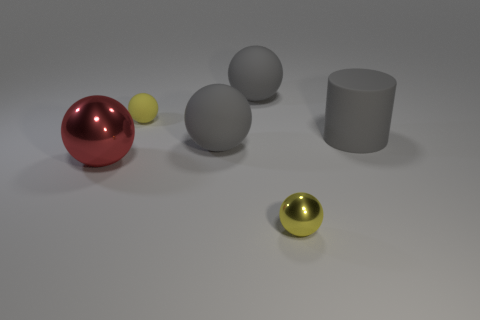Subtract all big rubber balls. How many balls are left? 3 Subtract all yellow balls. How many balls are left? 3 Subtract all red cylinders. How many gray balls are left? 2 Add 2 tiny matte balls. How many tiny matte balls are left? 3 Add 6 brown cylinders. How many brown cylinders exist? 6 Add 3 large cyan metal balls. How many objects exist? 9 Subtract 0 red cylinders. How many objects are left? 6 Subtract all spheres. How many objects are left? 1 Subtract 1 balls. How many balls are left? 4 Subtract all cyan cylinders. Subtract all purple cubes. How many cylinders are left? 1 